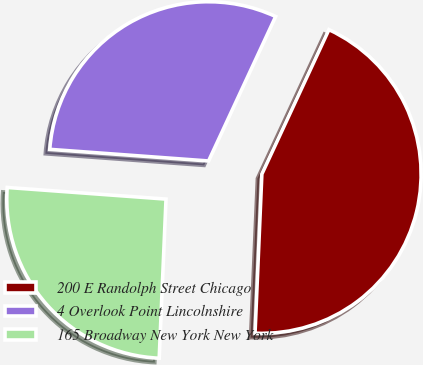Convert chart. <chart><loc_0><loc_0><loc_500><loc_500><pie_chart><fcel>200 E Randolph Street Chicago<fcel>4 Overlook Point Lincolnshire<fcel>165 Broadway New York New York<nl><fcel>43.76%<fcel>30.75%<fcel>25.48%<nl></chart> 